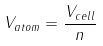<formula> <loc_0><loc_0><loc_500><loc_500>V _ { a t o m } = \frac { V _ { c e l l } } { n }</formula> 